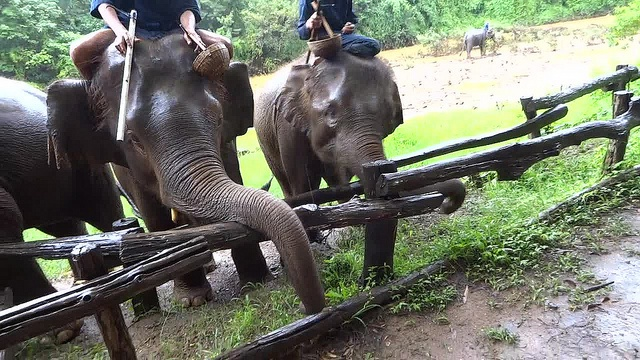Describe the objects in this image and their specific colors. I can see elephant in teal, black, gray, and darkgray tones, elephant in teal, black, white, gray, and darkgray tones, elephant in teal, gray, black, darkgray, and white tones, people in teal, black, white, gray, and navy tones, and people in teal, black, gray, navy, and darkgray tones in this image. 